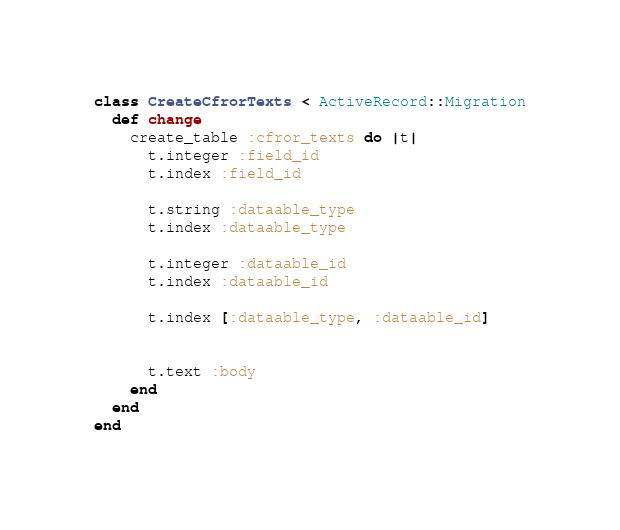Convert code to text. <code><loc_0><loc_0><loc_500><loc_500><_Ruby_>class CreateCfrorTexts < ActiveRecord::Migration
  def change
    create_table :cfror_texts do |t|
      t.integer :field_id
      t.index :field_id

      t.string :dataable_type
      t.index :dataable_type

      t.integer :dataable_id
      t.index :dataable_id

      t.index [:dataable_type, :dataable_id]

      
      t.text :body
    end
  end
end
</code> 